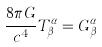<formula> <loc_0><loc_0><loc_500><loc_500>\frac { 8 \pi G } { c ^ { 4 } } T _ { \beta } ^ { \alpha } = G _ { \beta } ^ { \alpha }</formula> 